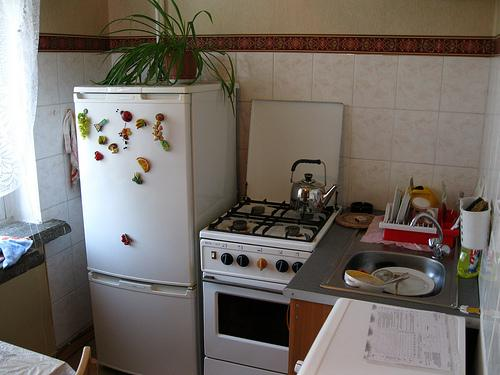Question: where are there magnets?
Choices:
A. Refrigerator.
B. Ice box.
C. Freezer.
D. The microwave.
Answer with the letter. Answer: A Question: what is atop the refrigerator?
Choices:
A. The bills.
B. A recipe folder.
C. The blender.
D. Plant.
Answer with the letter. Answer: D Question: where are there dirty dishes?
Choices:
A. Sink.
B. In dishwasher.
C. On the table.
D. Outside on picnic table.
Answer with the letter. Answer: A Question: where is the refrigerator's freezer door?
Choices:
A. Top.
B. Bottom.
C. Side.
D. Middle.
Answer with the letter. Answer: B Question: why would this room be used?
Choices:
A. To eat.
B. To clean.
C. To store food.
D. To cook.
Answer with the letter. Answer: D Question: how could the room be characterized, size-wise?
Choices:
A. Large.
B. Small.
C. Fitted.
D. Medium.
Answer with the letter. Answer: B 